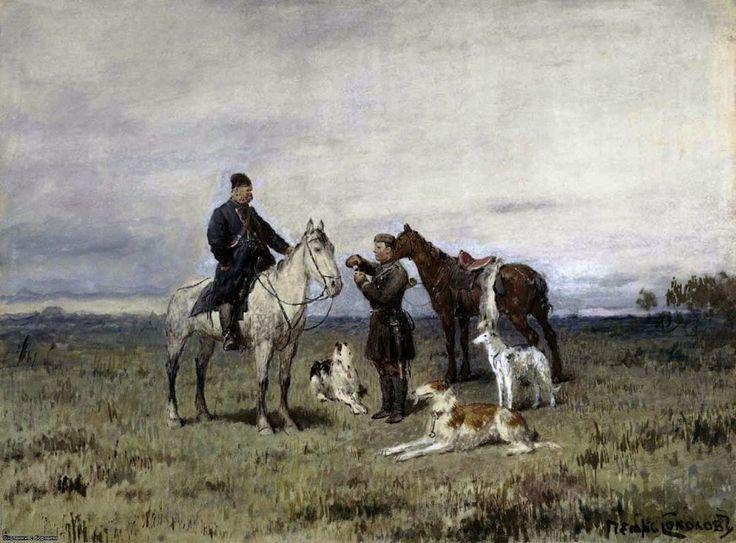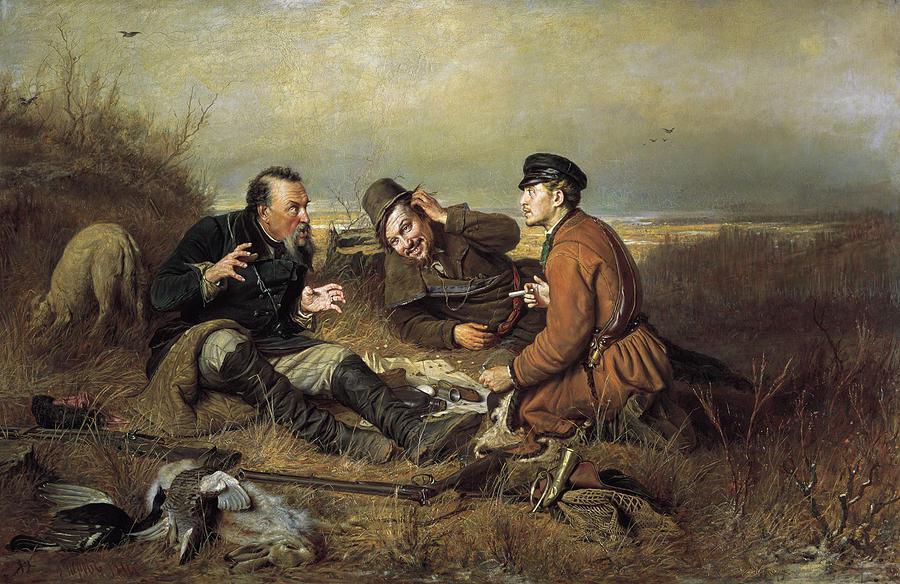The first image is the image on the left, the second image is the image on the right. Analyze the images presented: Is the assertion "One image shows at least one man on a horse with at least two dogs standing next to the horse, and the other image shows horses but no wagon." valid? Answer yes or no. No. 